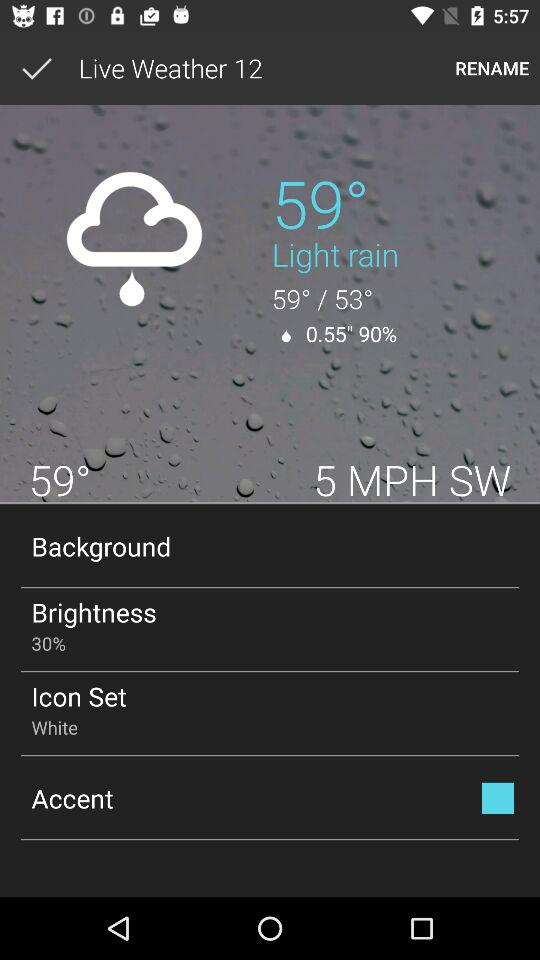How is the weather? The weather is lightly rainy. 